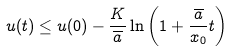Convert formula to latex. <formula><loc_0><loc_0><loc_500><loc_500>u ( t ) \leq u ( 0 ) - \frac { K } { \overline { a } } \ln \left ( 1 + \frac { \overline { a } } { x _ { 0 } } t \right ) \,</formula> 